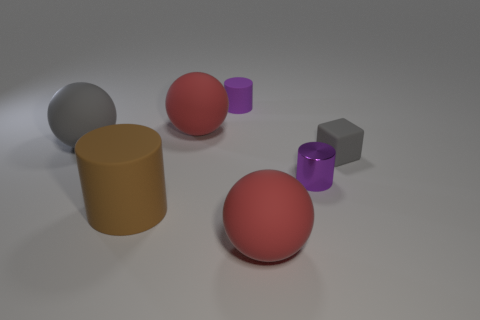Do the small rubber cylinder and the large rubber object that is behind the big gray rubber thing have the same color?
Make the answer very short. No. Is there a cyan matte cylinder of the same size as the gray block?
Make the answer very short. No. What is the size of the object that is the same color as the rubber block?
Your response must be concise. Large. There is a large red ball that is in front of the large brown cylinder; what is its material?
Your response must be concise. Rubber. Is the number of large things on the right side of the brown rubber object the same as the number of gray rubber things to the right of the small cube?
Ensure brevity in your answer.  No. Is the size of the rubber cylinder behind the brown thing the same as the red matte ball that is behind the gray rubber cube?
Offer a terse response. No. How many big rubber objects are the same color as the metal thing?
Provide a short and direct response. 0. What is the material of the cylinder that is the same color as the metallic object?
Keep it short and to the point. Rubber. Are there more big things that are in front of the small purple matte cylinder than tiny rubber things?
Your answer should be very brief. Yes. Does the large brown matte object have the same shape as the big gray thing?
Your answer should be compact. No. 